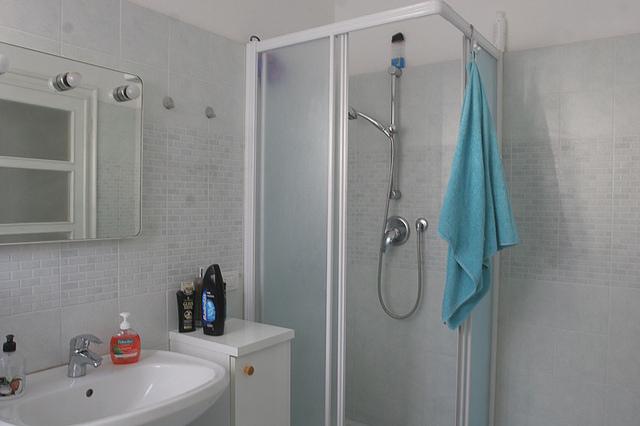How many types of soap are on the counter?
Short answer required. 2. Is this a modern bathroom?
Quick response, please. Yes. What color is the towel?
Be succinct. Blue. 